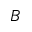Convert formula to latex. <formula><loc_0><loc_0><loc_500><loc_500>B</formula> 